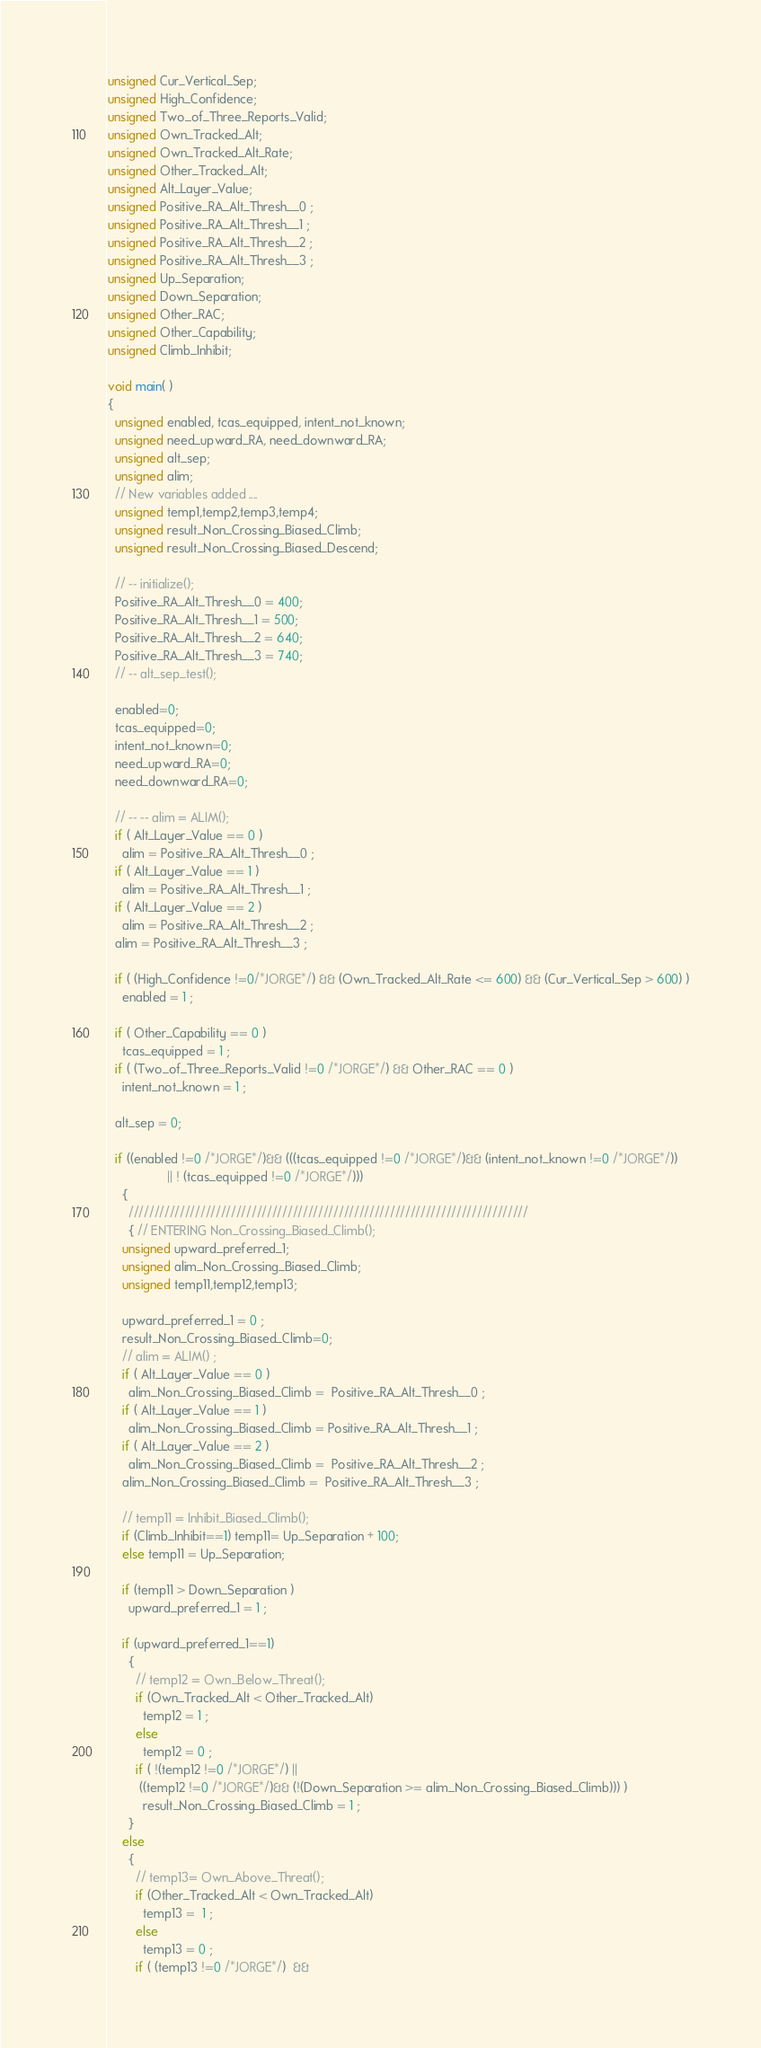Convert code to text. <code><loc_0><loc_0><loc_500><loc_500><_C_>unsigned Cur_Vertical_Sep;
unsigned High_Confidence;
unsigned Two_of_Three_Reports_Valid;
unsigned Own_Tracked_Alt;
unsigned Own_Tracked_Alt_Rate;
unsigned Other_Tracked_Alt;
unsigned Alt_Layer_Value;
unsigned Positive_RA_Alt_Thresh__0 ;
unsigned Positive_RA_Alt_Thresh__1 ;
unsigned Positive_RA_Alt_Thresh__2 ;
unsigned Positive_RA_Alt_Thresh__3 ;
unsigned Up_Separation;
unsigned Down_Separation;
unsigned Other_RAC;
unsigned Other_Capability;
unsigned Climb_Inhibit;

void main( )
{
  unsigned enabled, tcas_equipped, intent_not_known;
  unsigned need_upward_RA, need_downward_RA;
  unsigned alt_sep;
  unsigned alim;
  // New variables added ....
  unsigned temp1,temp2,temp3,temp4;
  unsigned result_Non_Crossing_Biased_Climb;
  unsigned result_Non_Crossing_Biased_Descend;   

  // -- initialize();
  Positive_RA_Alt_Thresh__0 = 400;
  Positive_RA_Alt_Thresh__1 = 500;
  Positive_RA_Alt_Thresh__2 = 640;
  Positive_RA_Alt_Thresh__3 = 740;
  // -- alt_sep_test();
  
  enabled=0;
  tcas_equipped=0;
  intent_not_known=0;
  need_upward_RA=0;
  need_downward_RA=0;

  // -- -- alim = ALIM();
  if ( Alt_Layer_Value == 0 )
    alim = Positive_RA_Alt_Thresh__0 ;
  if ( Alt_Layer_Value == 1 )
    alim = Positive_RA_Alt_Thresh__1 ;
  if ( Alt_Layer_Value == 2 )
    alim = Positive_RA_Alt_Thresh__2 ;
  alim = Positive_RA_Alt_Thresh__3 ;

  if ( (High_Confidence !=0/*JORGE*/) && (Own_Tracked_Alt_Rate <= 600) && (Cur_Vertical_Sep > 600) )
    enabled = 1 ;

  if ( Other_Capability == 0 )
    tcas_equipped = 1 ;
  if ( (Two_of_Three_Reports_Valid !=0 /*JORGE*/) && Other_RAC == 0 )
    intent_not_known = 1 ;
  
  alt_sep = 0;

  if ((enabled !=0 /*JORGE*/)&& (((tcas_equipped !=0 /*JORGE*/)&& (intent_not_known !=0 /*JORGE*/)) 
				 || ! (tcas_equipped !=0 /*JORGE*/)))
    {
      //////////////////////////////////////////////////////////////////////////////
      { // ENTERING Non_Crossing_Biased_Climb();
	unsigned upward_preferred_1;
	unsigned alim_Non_Crossing_Biased_Climb;
	unsigned temp11,temp12,temp13;

	upward_preferred_1 = 0 ;
	result_Non_Crossing_Biased_Climb=0;
	// alim = ALIM() ;
	if ( Alt_Layer_Value == 0 )
	  alim_Non_Crossing_Biased_Climb =  Positive_RA_Alt_Thresh__0 ;
	if ( Alt_Layer_Value == 1 )
	  alim_Non_Crossing_Biased_Climb = Positive_RA_Alt_Thresh__1 ;
	if ( Alt_Layer_Value == 2 )
	  alim_Non_Crossing_Biased_Climb =  Positive_RA_Alt_Thresh__2 ;
	alim_Non_Crossing_Biased_Climb =  Positive_RA_Alt_Thresh__3 ;

	// temp11 = Inhibit_Biased_Climb();
	if (Climb_Inhibit==1) temp11= Up_Separation + 100;
	else temp11 = Up_Separation;

	if (temp11 > Down_Separation )
	  upward_preferred_1 = 1 ;

	if (upward_preferred_1==1)
	  {
	    // temp12 = Own_Below_Threat();
	    if (Own_Tracked_Alt < Other_Tracked_Alt)
	      temp12 = 1 ;
	    else
	      temp12 = 0 ;
	    if ( !(temp12 !=0 /*JORGE*/) || 
		 ((temp12 !=0 /*JORGE*/)&& (!(Down_Separation >= alim_Non_Crossing_Biased_Climb))) )
	      result_Non_Crossing_Biased_Climb = 1 ;
	  }
	else
	  {
	    // temp13= Own_Above_Threat();
	    if (Other_Tracked_Alt < Own_Tracked_Alt)
	      temp13 =  1 ;
	    else
	      temp13 = 0 ;
	    if ( (temp13 !=0 /*JORGE*/)  && </code> 